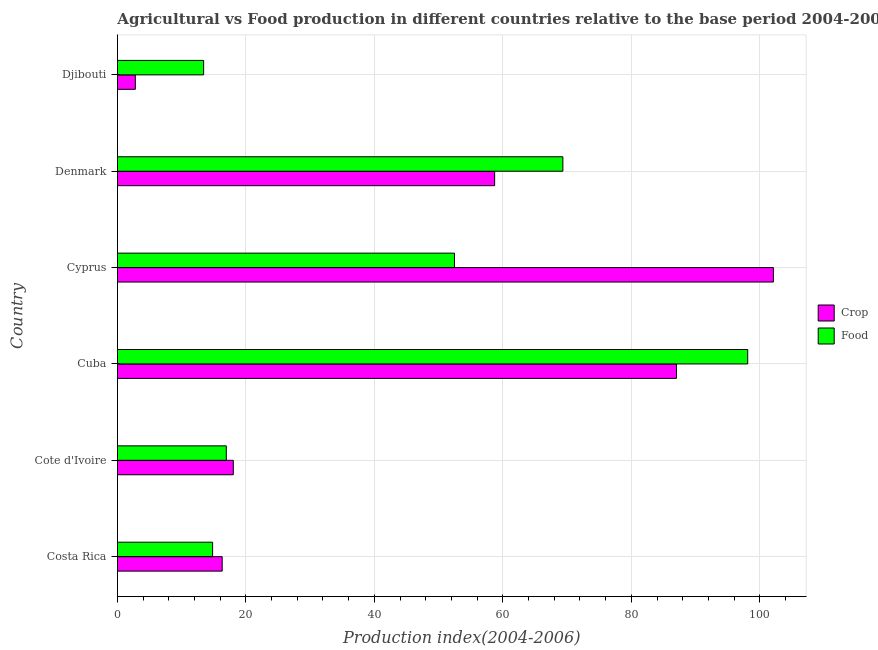How many groups of bars are there?
Your answer should be compact. 6. Are the number of bars per tick equal to the number of legend labels?
Keep it short and to the point. Yes. Are the number of bars on each tick of the Y-axis equal?
Keep it short and to the point. Yes. In how many cases, is the number of bars for a given country not equal to the number of legend labels?
Keep it short and to the point. 0. What is the crop production index in Cyprus?
Offer a very short reply. 102.11. Across all countries, what is the maximum food production index?
Offer a very short reply. 98.11. Across all countries, what is the minimum crop production index?
Offer a terse response. 2.79. In which country was the crop production index maximum?
Make the answer very short. Cyprus. In which country was the crop production index minimum?
Give a very brief answer. Djibouti. What is the total crop production index in the graph?
Offer a very short reply. 285. What is the difference between the food production index in Costa Rica and that in Cote d'Ivoire?
Offer a very short reply. -2.13. What is the difference between the food production index in Cote d'Ivoire and the crop production index in Denmark?
Make the answer very short. -41.77. What is the average food production index per country?
Your response must be concise. 44.19. What is the difference between the food production index and crop production index in Costa Rica?
Your answer should be very brief. -1.49. What is the ratio of the crop production index in Cote d'Ivoire to that in Denmark?
Keep it short and to the point. 0.31. Is the food production index in Cuba less than that in Cyprus?
Provide a succinct answer. No. Is the difference between the food production index in Cyprus and Denmark greater than the difference between the crop production index in Cyprus and Denmark?
Provide a succinct answer. No. What is the difference between the highest and the second highest crop production index?
Provide a succinct answer. 15.08. What is the difference between the highest and the lowest crop production index?
Keep it short and to the point. 99.32. In how many countries, is the food production index greater than the average food production index taken over all countries?
Make the answer very short. 3. Is the sum of the crop production index in Costa Rica and Cote d'Ivoire greater than the maximum food production index across all countries?
Keep it short and to the point. No. What does the 2nd bar from the top in Cuba represents?
Provide a short and direct response. Crop. What does the 2nd bar from the bottom in Cuba represents?
Offer a very short reply. Food. Are all the bars in the graph horizontal?
Offer a terse response. Yes. What is the difference between two consecutive major ticks on the X-axis?
Ensure brevity in your answer.  20. Are the values on the major ticks of X-axis written in scientific E-notation?
Ensure brevity in your answer.  No. Does the graph contain any zero values?
Keep it short and to the point. No. What is the title of the graph?
Keep it short and to the point. Agricultural vs Food production in different countries relative to the base period 2004-2006. Does "Tetanus" appear as one of the legend labels in the graph?
Give a very brief answer. No. What is the label or title of the X-axis?
Your answer should be compact. Production index(2004-2006). What is the Production index(2004-2006) in Crop in Costa Rica?
Your answer should be compact. 16.31. What is the Production index(2004-2006) in Food in Costa Rica?
Keep it short and to the point. 14.82. What is the Production index(2004-2006) in Crop in Cote d'Ivoire?
Your answer should be compact. 18.04. What is the Production index(2004-2006) of Food in Cote d'Ivoire?
Keep it short and to the point. 16.95. What is the Production index(2004-2006) in Crop in Cuba?
Make the answer very short. 87.03. What is the Production index(2004-2006) in Food in Cuba?
Provide a short and direct response. 98.11. What is the Production index(2004-2006) in Crop in Cyprus?
Your answer should be compact. 102.11. What is the Production index(2004-2006) of Food in Cyprus?
Give a very brief answer. 52.47. What is the Production index(2004-2006) of Crop in Denmark?
Offer a terse response. 58.72. What is the Production index(2004-2006) of Food in Denmark?
Provide a short and direct response. 69.34. What is the Production index(2004-2006) in Crop in Djibouti?
Offer a terse response. 2.79. What is the Production index(2004-2006) of Food in Djibouti?
Your answer should be compact. 13.42. Across all countries, what is the maximum Production index(2004-2006) in Crop?
Offer a terse response. 102.11. Across all countries, what is the maximum Production index(2004-2006) in Food?
Ensure brevity in your answer.  98.11. Across all countries, what is the minimum Production index(2004-2006) in Crop?
Offer a very short reply. 2.79. Across all countries, what is the minimum Production index(2004-2006) of Food?
Your response must be concise. 13.42. What is the total Production index(2004-2006) of Crop in the graph?
Give a very brief answer. 285. What is the total Production index(2004-2006) of Food in the graph?
Your answer should be compact. 265.11. What is the difference between the Production index(2004-2006) of Crop in Costa Rica and that in Cote d'Ivoire?
Your answer should be very brief. -1.73. What is the difference between the Production index(2004-2006) of Food in Costa Rica and that in Cote d'Ivoire?
Provide a succinct answer. -2.13. What is the difference between the Production index(2004-2006) in Crop in Costa Rica and that in Cuba?
Your answer should be very brief. -70.72. What is the difference between the Production index(2004-2006) of Food in Costa Rica and that in Cuba?
Provide a succinct answer. -83.29. What is the difference between the Production index(2004-2006) of Crop in Costa Rica and that in Cyprus?
Ensure brevity in your answer.  -85.8. What is the difference between the Production index(2004-2006) in Food in Costa Rica and that in Cyprus?
Your answer should be compact. -37.65. What is the difference between the Production index(2004-2006) of Crop in Costa Rica and that in Denmark?
Give a very brief answer. -42.41. What is the difference between the Production index(2004-2006) of Food in Costa Rica and that in Denmark?
Offer a terse response. -54.52. What is the difference between the Production index(2004-2006) in Crop in Costa Rica and that in Djibouti?
Your answer should be very brief. 13.52. What is the difference between the Production index(2004-2006) in Crop in Cote d'Ivoire and that in Cuba?
Keep it short and to the point. -68.99. What is the difference between the Production index(2004-2006) in Food in Cote d'Ivoire and that in Cuba?
Offer a very short reply. -81.16. What is the difference between the Production index(2004-2006) of Crop in Cote d'Ivoire and that in Cyprus?
Provide a short and direct response. -84.07. What is the difference between the Production index(2004-2006) in Food in Cote d'Ivoire and that in Cyprus?
Provide a succinct answer. -35.52. What is the difference between the Production index(2004-2006) of Crop in Cote d'Ivoire and that in Denmark?
Provide a short and direct response. -40.68. What is the difference between the Production index(2004-2006) in Food in Cote d'Ivoire and that in Denmark?
Give a very brief answer. -52.39. What is the difference between the Production index(2004-2006) in Crop in Cote d'Ivoire and that in Djibouti?
Your answer should be very brief. 15.25. What is the difference between the Production index(2004-2006) in Food in Cote d'Ivoire and that in Djibouti?
Provide a succinct answer. 3.53. What is the difference between the Production index(2004-2006) in Crop in Cuba and that in Cyprus?
Ensure brevity in your answer.  -15.08. What is the difference between the Production index(2004-2006) in Food in Cuba and that in Cyprus?
Keep it short and to the point. 45.64. What is the difference between the Production index(2004-2006) of Crop in Cuba and that in Denmark?
Provide a succinct answer. 28.31. What is the difference between the Production index(2004-2006) of Food in Cuba and that in Denmark?
Your response must be concise. 28.77. What is the difference between the Production index(2004-2006) in Crop in Cuba and that in Djibouti?
Provide a short and direct response. 84.24. What is the difference between the Production index(2004-2006) of Food in Cuba and that in Djibouti?
Your answer should be compact. 84.69. What is the difference between the Production index(2004-2006) in Crop in Cyprus and that in Denmark?
Make the answer very short. 43.39. What is the difference between the Production index(2004-2006) in Food in Cyprus and that in Denmark?
Give a very brief answer. -16.87. What is the difference between the Production index(2004-2006) of Crop in Cyprus and that in Djibouti?
Your answer should be compact. 99.32. What is the difference between the Production index(2004-2006) in Food in Cyprus and that in Djibouti?
Keep it short and to the point. 39.05. What is the difference between the Production index(2004-2006) of Crop in Denmark and that in Djibouti?
Your answer should be very brief. 55.93. What is the difference between the Production index(2004-2006) of Food in Denmark and that in Djibouti?
Offer a very short reply. 55.92. What is the difference between the Production index(2004-2006) in Crop in Costa Rica and the Production index(2004-2006) in Food in Cote d'Ivoire?
Offer a very short reply. -0.64. What is the difference between the Production index(2004-2006) of Crop in Costa Rica and the Production index(2004-2006) of Food in Cuba?
Provide a short and direct response. -81.8. What is the difference between the Production index(2004-2006) of Crop in Costa Rica and the Production index(2004-2006) of Food in Cyprus?
Offer a very short reply. -36.16. What is the difference between the Production index(2004-2006) of Crop in Costa Rica and the Production index(2004-2006) of Food in Denmark?
Provide a succinct answer. -53.03. What is the difference between the Production index(2004-2006) of Crop in Costa Rica and the Production index(2004-2006) of Food in Djibouti?
Give a very brief answer. 2.89. What is the difference between the Production index(2004-2006) in Crop in Cote d'Ivoire and the Production index(2004-2006) in Food in Cuba?
Provide a short and direct response. -80.07. What is the difference between the Production index(2004-2006) of Crop in Cote d'Ivoire and the Production index(2004-2006) of Food in Cyprus?
Ensure brevity in your answer.  -34.43. What is the difference between the Production index(2004-2006) of Crop in Cote d'Ivoire and the Production index(2004-2006) of Food in Denmark?
Make the answer very short. -51.3. What is the difference between the Production index(2004-2006) of Crop in Cote d'Ivoire and the Production index(2004-2006) of Food in Djibouti?
Make the answer very short. 4.62. What is the difference between the Production index(2004-2006) of Crop in Cuba and the Production index(2004-2006) of Food in Cyprus?
Give a very brief answer. 34.56. What is the difference between the Production index(2004-2006) of Crop in Cuba and the Production index(2004-2006) of Food in Denmark?
Provide a short and direct response. 17.69. What is the difference between the Production index(2004-2006) in Crop in Cuba and the Production index(2004-2006) in Food in Djibouti?
Your answer should be compact. 73.61. What is the difference between the Production index(2004-2006) in Crop in Cyprus and the Production index(2004-2006) in Food in Denmark?
Ensure brevity in your answer.  32.77. What is the difference between the Production index(2004-2006) in Crop in Cyprus and the Production index(2004-2006) in Food in Djibouti?
Provide a succinct answer. 88.69. What is the difference between the Production index(2004-2006) of Crop in Denmark and the Production index(2004-2006) of Food in Djibouti?
Your answer should be very brief. 45.3. What is the average Production index(2004-2006) in Crop per country?
Provide a succinct answer. 47.5. What is the average Production index(2004-2006) in Food per country?
Your answer should be compact. 44.19. What is the difference between the Production index(2004-2006) in Crop and Production index(2004-2006) in Food in Costa Rica?
Keep it short and to the point. 1.49. What is the difference between the Production index(2004-2006) of Crop and Production index(2004-2006) of Food in Cote d'Ivoire?
Your response must be concise. 1.09. What is the difference between the Production index(2004-2006) of Crop and Production index(2004-2006) of Food in Cuba?
Ensure brevity in your answer.  -11.08. What is the difference between the Production index(2004-2006) in Crop and Production index(2004-2006) in Food in Cyprus?
Provide a short and direct response. 49.64. What is the difference between the Production index(2004-2006) of Crop and Production index(2004-2006) of Food in Denmark?
Offer a very short reply. -10.62. What is the difference between the Production index(2004-2006) of Crop and Production index(2004-2006) of Food in Djibouti?
Offer a very short reply. -10.63. What is the ratio of the Production index(2004-2006) of Crop in Costa Rica to that in Cote d'Ivoire?
Your response must be concise. 0.9. What is the ratio of the Production index(2004-2006) in Food in Costa Rica to that in Cote d'Ivoire?
Ensure brevity in your answer.  0.87. What is the ratio of the Production index(2004-2006) of Crop in Costa Rica to that in Cuba?
Your answer should be very brief. 0.19. What is the ratio of the Production index(2004-2006) of Food in Costa Rica to that in Cuba?
Your answer should be very brief. 0.15. What is the ratio of the Production index(2004-2006) in Crop in Costa Rica to that in Cyprus?
Keep it short and to the point. 0.16. What is the ratio of the Production index(2004-2006) of Food in Costa Rica to that in Cyprus?
Keep it short and to the point. 0.28. What is the ratio of the Production index(2004-2006) in Crop in Costa Rica to that in Denmark?
Give a very brief answer. 0.28. What is the ratio of the Production index(2004-2006) of Food in Costa Rica to that in Denmark?
Ensure brevity in your answer.  0.21. What is the ratio of the Production index(2004-2006) in Crop in Costa Rica to that in Djibouti?
Make the answer very short. 5.85. What is the ratio of the Production index(2004-2006) in Food in Costa Rica to that in Djibouti?
Offer a terse response. 1.1. What is the ratio of the Production index(2004-2006) of Crop in Cote d'Ivoire to that in Cuba?
Offer a terse response. 0.21. What is the ratio of the Production index(2004-2006) in Food in Cote d'Ivoire to that in Cuba?
Make the answer very short. 0.17. What is the ratio of the Production index(2004-2006) of Crop in Cote d'Ivoire to that in Cyprus?
Ensure brevity in your answer.  0.18. What is the ratio of the Production index(2004-2006) of Food in Cote d'Ivoire to that in Cyprus?
Your answer should be very brief. 0.32. What is the ratio of the Production index(2004-2006) in Crop in Cote d'Ivoire to that in Denmark?
Ensure brevity in your answer.  0.31. What is the ratio of the Production index(2004-2006) in Food in Cote d'Ivoire to that in Denmark?
Ensure brevity in your answer.  0.24. What is the ratio of the Production index(2004-2006) in Crop in Cote d'Ivoire to that in Djibouti?
Make the answer very short. 6.47. What is the ratio of the Production index(2004-2006) in Food in Cote d'Ivoire to that in Djibouti?
Provide a short and direct response. 1.26. What is the ratio of the Production index(2004-2006) of Crop in Cuba to that in Cyprus?
Keep it short and to the point. 0.85. What is the ratio of the Production index(2004-2006) of Food in Cuba to that in Cyprus?
Offer a terse response. 1.87. What is the ratio of the Production index(2004-2006) of Crop in Cuba to that in Denmark?
Make the answer very short. 1.48. What is the ratio of the Production index(2004-2006) in Food in Cuba to that in Denmark?
Your response must be concise. 1.41. What is the ratio of the Production index(2004-2006) in Crop in Cuba to that in Djibouti?
Offer a very short reply. 31.19. What is the ratio of the Production index(2004-2006) of Food in Cuba to that in Djibouti?
Make the answer very short. 7.31. What is the ratio of the Production index(2004-2006) in Crop in Cyprus to that in Denmark?
Keep it short and to the point. 1.74. What is the ratio of the Production index(2004-2006) of Food in Cyprus to that in Denmark?
Offer a terse response. 0.76. What is the ratio of the Production index(2004-2006) in Crop in Cyprus to that in Djibouti?
Your response must be concise. 36.6. What is the ratio of the Production index(2004-2006) in Food in Cyprus to that in Djibouti?
Ensure brevity in your answer.  3.91. What is the ratio of the Production index(2004-2006) of Crop in Denmark to that in Djibouti?
Make the answer very short. 21.05. What is the ratio of the Production index(2004-2006) of Food in Denmark to that in Djibouti?
Ensure brevity in your answer.  5.17. What is the difference between the highest and the second highest Production index(2004-2006) of Crop?
Keep it short and to the point. 15.08. What is the difference between the highest and the second highest Production index(2004-2006) of Food?
Offer a very short reply. 28.77. What is the difference between the highest and the lowest Production index(2004-2006) in Crop?
Keep it short and to the point. 99.32. What is the difference between the highest and the lowest Production index(2004-2006) of Food?
Your answer should be very brief. 84.69. 